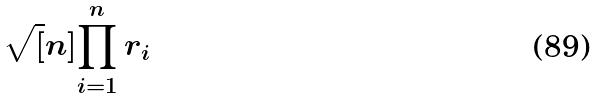Convert formula to latex. <formula><loc_0><loc_0><loc_500><loc_500>\sqrt { [ } n ] { \prod _ { i = 1 } ^ { n } r _ { i } }</formula> 